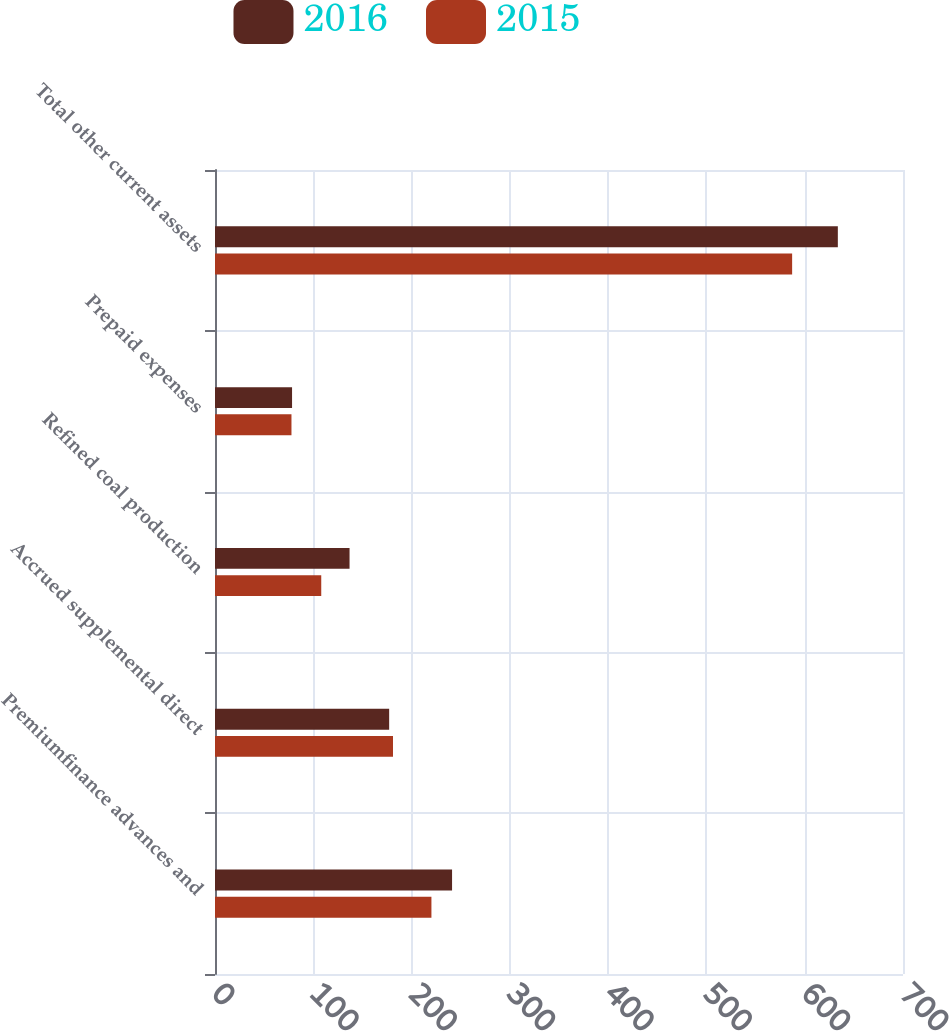Convert chart to OTSL. <chart><loc_0><loc_0><loc_500><loc_500><stacked_bar_chart><ecel><fcel>Premiumfinance advances and<fcel>Accrued supplemental direct<fcel>Refined coal production<fcel>Prepaid expenses<fcel>Total other current assets<nl><fcel>2016<fcel>241.2<fcel>177.2<fcel>136.9<fcel>78.4<fcel>633.7<nl><fcel>2015<fcel>220.2<fcel>181.1<fcel>108.1<fcel>77.8<fcel>587.2<nl></chart> 